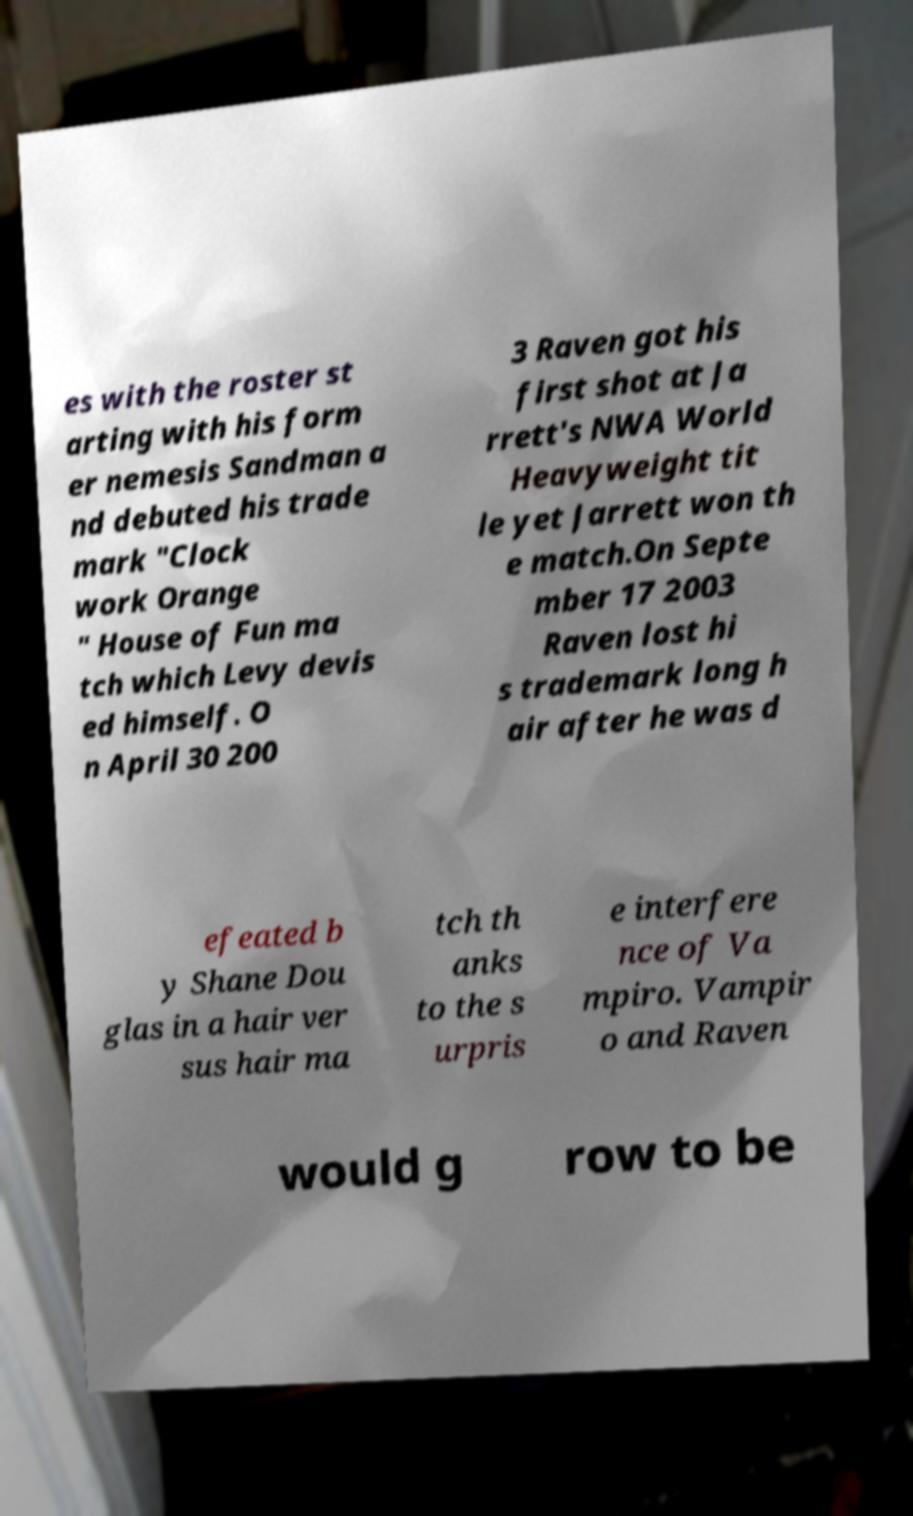For documentation purposes, I need the text within this image transcribed. Could you provide that? es with the roster st arting with his form er nemesis Sandman a nd debuted his trade mark "Clock work Orange " House of Fun ma tch which Levy devis ed himself. O n April 30 200 3 Raven got his first shot at Ja rrett's NWA World Heavyweight tit le yet Jarrett won th e match.On Septe mber 17 2003 Raven lost hi s trademark long h air after he was d efeated b y Shane Dou glas in a hair ver sus hair ma tch th anks to the s urpris e interfere nce of Va mpiro. Vampir o and Raven would g row to be 